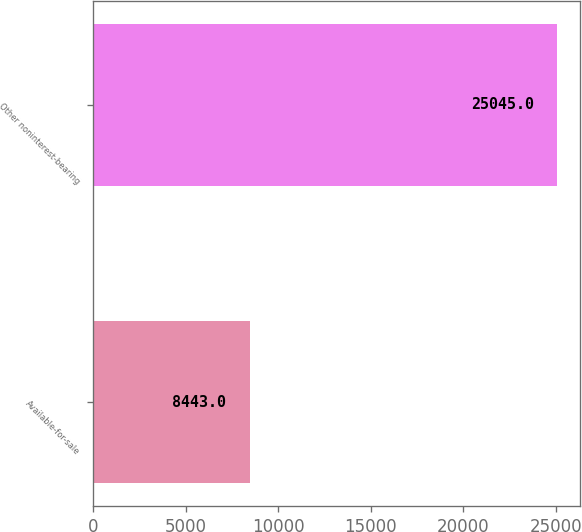Convert chart to OTSL. <chart><loc_0><loc_0><loc_500><loc_500><bar_chart><fcel>Available-for-sale<fcel>Other noninterest-bearing<nl><fcel>8443<fcel>25045<nl></chart> 